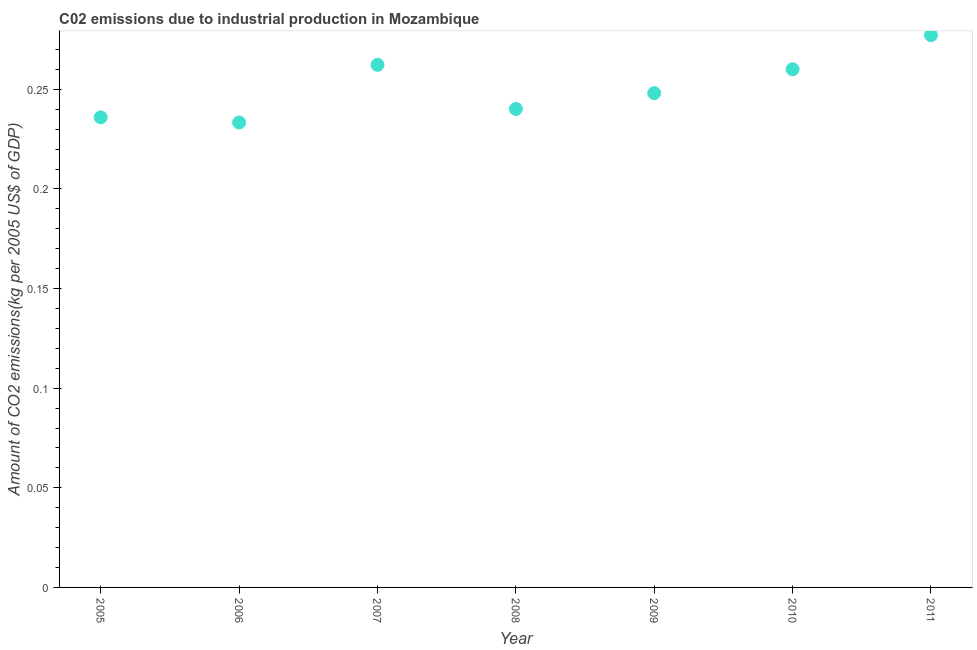What is the amount of co2 emissions in 2011?
Your answer should be compact. 0.28. Across all years, what is the maximum amount of co2 emissions?
Ensure brevity in your answer.  0.28. Across all years, what is the minimum amount of co2 emissions?
Ensure brevity in your answer.  0.23. In which year was the amount of co2 emissions maximum?
Provide a succinct answer. 2011. What is the sum of the amount of co2 emissions?
Your answer should be compact. 1.76. What is the difference between the amount of co2 emissions in 2008 and 2011?
Offer a very short reply. -0.04. What is the average amount of co2 emissions per year?
Give a very brief answer. 0.25. What is the median amount of co2 emissions?
Keep it short and to the point. 0.25. Do a majority of the years between 2007 and 2005 (inclusive) have amount of co2 emissions greater than 0.05 kg per 2005 US$ of GDP?
Your response must be concise. No. What is the ratio of the amount of co2 emissions in 2007 to that in 2009?
Provide a succinct answer. 1.06. What is the difference between the highest and the second highest amount of co2 emissions?
Provide a succinct answer. 0.01. Is the sum of the amount of co2 emissions in 2008 and 2010 greater than the maximum amount of co2 emissions across all years?
Provide a succinct answer. Yes. What is the difference between the highest and the lowest amount of co2 emissions?
Your answer should be very brief. 0.04. How many dotlines are there?
Ensure brevity in your answer.  1. What is the difference between two consecutive major ticks on the Y-axis?
Give a very brief answer. 0.05. What is the title of the graph?
Provide a succinct answer. C02 emissions due to industrial production in Mozambique. What is the label or title of the X-axis?
Provide a short and direct response. Year. What is the label or title of the Y-axis?
Your answer should be compact. Amount of CO2 emissions(kg per 2005 US$ of GDP). What is the Amount of CO2 emissions(kg per 2005 US$ of GDP) in 2005?
Offer a terse response. 0.24. What is the Amount of CO2 emissions(kg per 2005 US$ of GDP) in 2006?
Provide a succinct answer. 0.23. What is the Amount of CO2 emissions(kg per 2005 US$ of GDP) in 2007?
Provide a succinct answer. 0.26. What is the Amount of CO2 emissions(kg per 2005 US$ of GDP) in 2008?
Your answer should be very brief. 0.24. What is the Amount of CO2 emissions(kg per 2005 US$ of GDP) in 2009?
Your response must be concise. 0.25. What is the Amount of CO2 emissions(kg per 2005 US$ of GDP) in 2010?
Provide a short and direct response. 0.26. What is the Amount of CO2 emissions(kg per 2005 US$ of GDP) in 2011?
Your response must be concise. 0.28. What is the difference between the Amount of CO2 emissions(kg per 2005 US$ of GDP) in 2005 and 2006?
Your answer should be compact. 0. What is the difference between the Amount of CO2 emissions(kg per 2005 US$ of GDP) in 2005 and 2007?
Your answer should be very brief. -0.03. What is the difference between the Amount of CO2 emissions(kg per 2005 US$ of GDP) in 2005 and 2008?
Give a very brief answer. -0. What is the difference between the Amount of CO2 emissions(kg per 2005 US$ of GDP) in 2005 and 2009?
Keep it short and to the point. -0.01. What is the difference between the Amount of CO2 emissions(kg per 2005 US$ of GDP) in 2005 and 2010?
Provide a short and direct response. -0.02. What is the difference between the Amount of CO2 emissions(kg per 2005 US$ of GDP) in 2005 and 2011?
Offer a terse response. -0.04. What is the difference between the Amount of CO2 emissions(kg per 2005 US$ of GDP) in 2006 and 2007?
Make the answer very short. -0.03. What is the difference between the Amount of CO2 emissions(kg per 2005 US$ of GDP) in 2006 and 2008?
Provide a short and direct response. -0.01. What is the difference between the Amount of CO2 emissions(kg per 2005 US$ of GDP) in 2006 and 2009?
Your answer should be very brief. -0.01. What is the difference between the Amount of CO2 emissions(kg per 2005 US$ of GDP) in 2006 and 2010?
Ensure brevity in your answer.  -0.03. What is the difference between the Amount of CO2 emissions(kg per 2005 US$ of GDP) in 2006 and 2011?
Provide a succinct answer. -0.04. What is the difference between the Amount of CO2 emissions(kg per 2005 US$ of GDP) in 2007 and 2008?
Provide a short and direct response. 0.02. What is the difference between the Amount of CO2 emissions(kg per 2005 US$ of GDP) in 2007 and 2009?
Provide a short and direct response. 0.01. What is the difference between the Amount of CO2 emissions(kg per 2005 US$ of GDP) in 2007 and 2010?
Provide a short and direct response. 0. What is the difference between the Amount of CO2 emissions(kg per 2005 US$ of GDP) in 2007 and 2011?
Ensure brevity in your answer.  -0.01. What is the difference between the Amount of CO2 emissions(kg per 2005 US$ of GDP) in 2008 and 2009?
Ensure brevity in your answer.  -0.01. What is the difference between the Amount of CO2 emissions(kg per 2005 US$ of GDP) in 2008 and 2010?
Offer a very short reply. -0.02. What is the difference between the Amount of CO2 emissions(kg per 2005 US$ of GDP) in 2008 and 2011?
Provide a short and direct response. -0.04. What is the difference between the Amount of CO2 emissions(kg per 2005 US$ of GDP) in 2009 and 2010?
Your answer should be very brief. -0.01. What is the difference between the Amount of CO2 emissions(kg per 2005 US$ of GDP) in 2009 and 2011?
Provide a succinct answer. -0.03. What is the difference between the Amount of CO2 emissions(kg per 2005 US$ of GDP) in 2010 and 2011?
Your answer should be very brief. -0.02. What is the ratio of the Amount of CO2 emissions(kg per 2005 US$ of GDP) in 2005 to that in 2007?
Offer a terse response. 0.9. What is the ratio of the Amount of CO2 emissions(kg per 2005 US$ of GDP) in 2005 to that in 2008?
Your answer should be compact. 0.98. What is the ratio of the Amount of CO2 emissions(kg per 2005 US$ of GDP) in 2005 to that in 2009?
Make the answer very short. 0.95. What is the ratio of the Amount of CO2 emissions(kg per 2005 US$ of GDP) in 2005 to that in 2010?
Provide a short and direct response. 0.91. What is the ratio of the Amount of CO2 emissions(kg per 2005 US$ of GDP) in 2005 to that in 2011?
Your answer should be very brief. 0.85. What is the ratio of the Amount of CO2 emissions(kg per 2005 US$ of GDP) in 2006 to that in 2007?
Give a very brief answer. 0.89. What is the ratio of the Amount of CO2 emissions(kg per 2005 US$ of GDP) in 2006 to that in 2009?
Offer a very short reply. 0.94. What is the ratio of the Amount of CO2 emissions(kg per 2005 US$ of GDP) in 2006 to that in 2010?
Give a very brief answer. 0.9. What is the ratio of the Amount of CO2 emissions(kg per 2005 US$ of GDP) in 2006 to that in 2011?
Your answer should be compact. 0.84. What is the ratio of the Amount of CO2 emissions(kg per 2005 US$ of GDP) in 2007 to that in 2008?
Offer a terse response. 1.09. What is the ratio of the Amount of CO2 emissions(kg per 2005 US$ of GDP) in 2007 to that in 2009?
Your response must be concise. 1.06. What is the ratio of the Amount of CO2 emissions(kg per 2005 US$ of GDP) in 2007 to that in 2011?
Your answer should be compact. 0.95. What is the ratio of the Amount of CO2 emissions(kg per 2005 US$ of GDP) in 2008 to that in 2009?
Your response must be concise. 0.97. What is the ratio of the Amount of CO2 emissions(kg per 2005 US$ of GDP) in 2008 to that in 2010?
Your answer should be compact. 0.92. What is the ratio of the Amount of CO2 emissions(kg per 2005 US$ of GDP) in 2008 to that in 2011?
Offer a terse response. 0.87. What is the ratio of the Amount of CO2 emissions(kg per 2005 US$ of GDP) in 2009 to that in 2010?
Your answer should be very brief. 0.95. What is the ratio of the Amount of CO2 emissions(kg per 2005 US$ of GDP) in 2009 to that in 2011?
Your answer should be compact. 0.9. What is the ratio of the Amount of CO2 emissions(kg per 2005 US$ of GDP) in 2010 to that in 2011?
Offer a terse response. 0.94. 